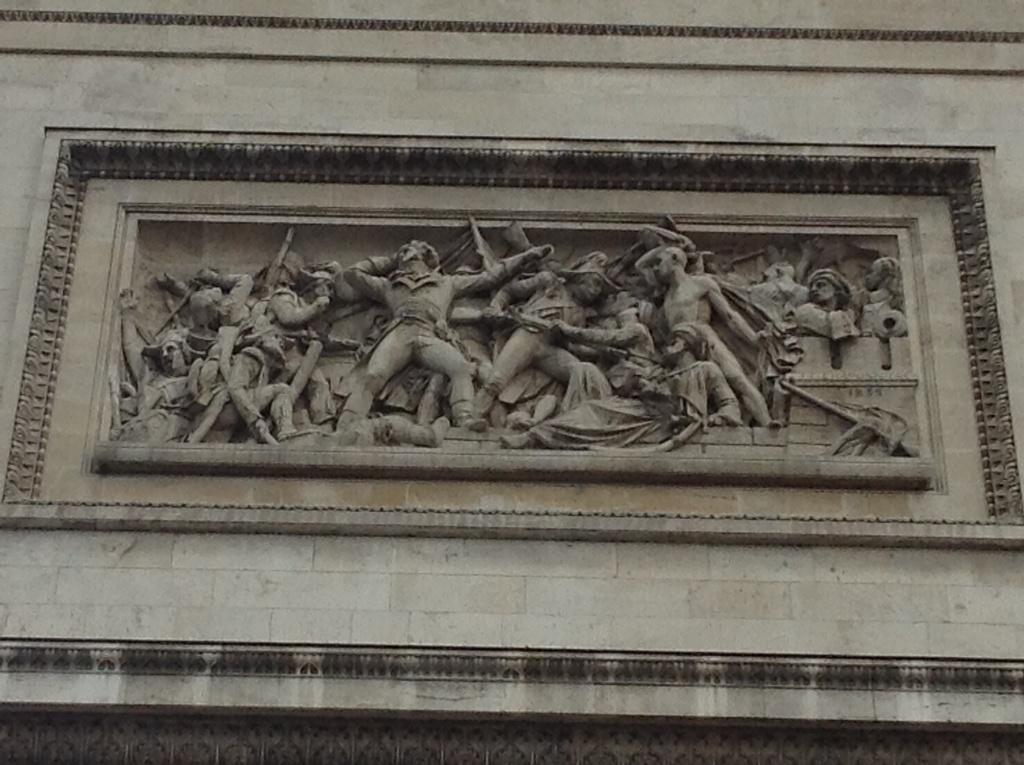What type of artwork is present in the image? There are sculptures in the image. What else can be seen in the image besides the sculptures? There is a wall in the image. What type of meal is being prepared in the image? There is no meal preparation visible in the image; it only features sculptures and a wall. 